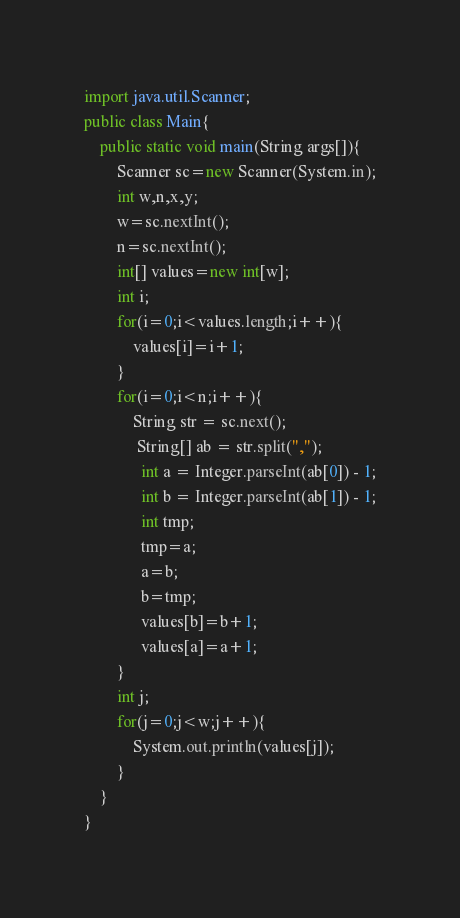<code> <loc_0><loc_0><loc_500><loc_500><_Java_>import java.util.Scanner;
public class Main{
    public static void main(String args[]){
        Scanner sc=new Scanner(System.in);
        int w,n,x,y;
        w=sc.nextInt();
        n=sc.nextInt();
        int[] values=new int[w];
        int i;
        for(i=0;i<values.length;i++){
            values[i]=i+1;
        }
        for(i=0;i<n;i++){
            String str = sc.next();
             String[] ab = str.split(",");
              int a = Integer.parseInt(ab[0]) - 1;
              int b = Integer.parseInt(ab[1]) - 1;
              int tmp;
              tmp=a;
              a=b;
              b=tmp;
              values[b]=b+1;
              values[a]=a+1;
        }
        int j;
        for(j=0;j<w;j++){
            System.out.println(values[j]);
        }
    }
}
</code> 